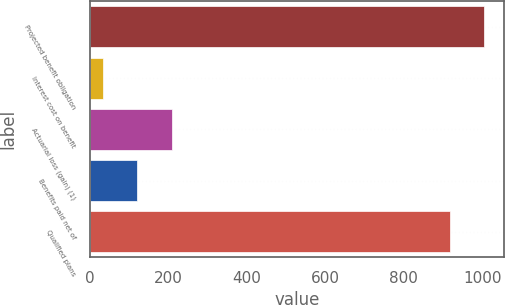Convert chart to OTSL. <chart><loc_0><loc_0><loc_500><loc_500><bar_chart><fcel>Projected benefit obligation<fcel>Interest cost on benefit<fcel>Actuarial loss (gain) (1)<fcel>Benefits paid net of<fcel>Qualified plans<nl><fcel>1005.4<fcel>33<fcel>209.8<fcel>121.4<fcel>917<nl></chart> 